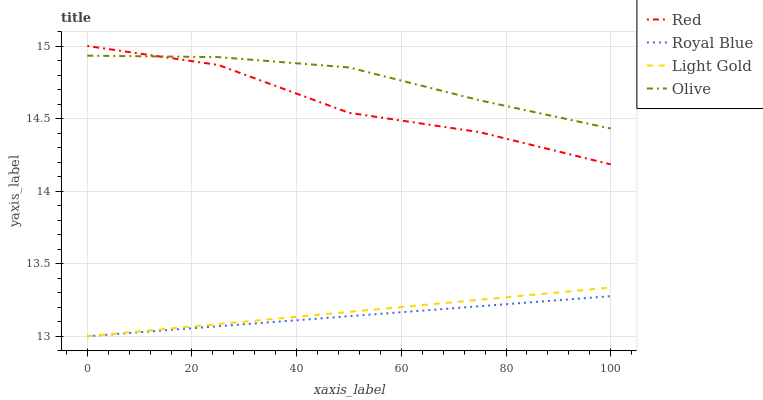Does Royal Blue have the minimum area under the curve?
Answer yes or no. Yes. Does Olive have the maximum area under the curve?
Answer yes or no. Yes. Does Light Gold have the minimum area under the curve?
Answer yes or no. No. Does Light Gold have the maximum area under the curve?
Answer yes or no. No. Is Light Gold the smoothest?
Answer yes or no. Yes. Is Red the roughest?
Answer yes or no. Yes. Is Royal Blue the smoothest?
Answer yes or no. No. Is Royal Blue the roughest?
Answer yes or no. No. Does Royal Blue have the lowest value?
Answer yes or no. Yes. Does Red have the lowest value?
Answer yes or no. No. Does Red have the highest value?
Answer yes or no. Yes. Does Light Gold have the highest value?
Answer yes or no. No. Is Royal Blue less than Olive?
Answer yes or no. Yes. Is Red greater than Royal Blue?
Answer yes or no. Yes. Does Royal Blue intersect Light Gold?
Answer yes or no. Yes. Is Royal Blue less than Light Gold?
Answer yes or no. No. Is Royal Blue greater than Light Gold?
Answer yes or no. No. Does Royal Blue intersect Olive?
Answer yes or no. No. 